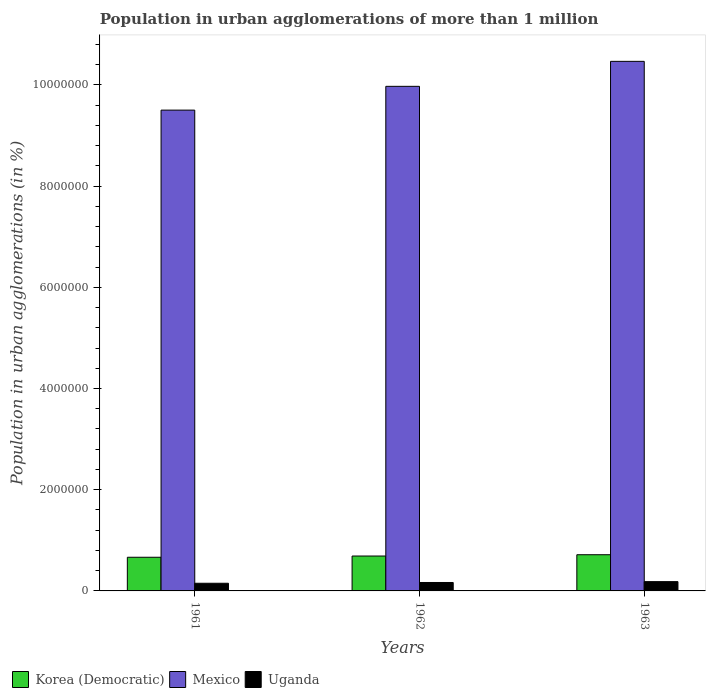How many groups of bars are there?
Your answer should be compact. 3. In how many cases, is the number of bars for a given year not equal to the number of legend labels?
Your answer should be very brief. 0. What is the population in urban agglomerations in Uganda in 1962?
Your response must be concise. 1.67e+05. Across all years, what is the maximum population in urban agglomerations in Mexico?
Your answer should be compact. 1.05e+07. Across all years, what is the minimum population in urban agglomerations in Mexico?
Offer a terse response. 9.50e+06. In which year was the population in urban agglomerations in Korea (Democratic) maximum?
Your answer should be very brief. 1963. In which year was the population in urban agglomerations in Korea (Democratic) minimum?
Provide a succinct answer. 1961. What is the total population in urban agglomerations in Uganda in the graph?
Ensure brevity in your answer.  5.01e+05. What is the difference between the population in urban agglomerations in Uganda in 1961 and that in 1963?
Offer a very short reply. -3.21e+04. What is the difference between the population in urban agglomerations in Korea (Democratic) in 1963 and the population in urban agglomerations in Mexico in 1961?
Ensure brevity in your answer.  -8.79e+06. What is the average population in urban agglomerations in Uganda per year?
Provide a succinct answer. 1.67e+05. In the year 1961, what is the difference between the population in urban agglomerations in Korea (Democratic) and population in urban agglomerations in Uganda?
Your response must be concise. 5.14e+05. In how many years, is the population in urban agglomerations in Uganda greater than 4400000 %?
Give a very brief answer. 0. What is the ratio of the population in urban agglomerations in Mexico in 1962 to that in 1963?
Keep it short and to the point. 0.95. What is the difference between the highest and the second highest population in urban agglomerations in Mexico?
Give a very brief answer. 4.94e+05. What is the difference between the highest and the lowest population in urban agglomerations in Mexico?
Provide a short and direct response. 9.64e+05. Is the sum of the population in urban agglomerations in Korea (Democratic) in 1961 and 1963 greater than the maximum population in urban agglomerations in Mexico across all years?
Your response must be concise. No. What does the 3rd bar from the left in 1963 represents?
Ensure brevity in your answer.  Uganda. What does the 1st bar from the right in 1961 represents?
Keep it short and to the point. Uganda. Is it the case that in every year, the sum of the population in urban agglomerations in Uganda and population in urban agglomerations in Mexico is greater than the population in urban agglomerations in Korea (Democratic)?
Provide a short and direct response. Yes. Are all the bars in the graph horizontal?
Keep it short and to the point. No. How many years are there in the graph?
Your answer should be very brief. 3. What is the difference between two consecutive major ticks on the Y-axis?
Provide a succinct answer. 2.00e+06. Does the graph contain grids?
Make the answer very short. No. Where does the legend appear in the graph?
Provide a short and direct response. Bottom left. How many legend labels are there?
Keep it short and to the point. 3. What is the title of the graph?
Ensure brevity in your answer.  Population in urban agglomerations of more than 1 million. Does "Guyana" appear as one of the legend labels in the graph?
Keep it short and to the point. No. What is the label or title of the Y-axis?
Provide a succinct answer. Population in urban agglomerations (in %). What is the Population in urban agglomerations (in %) of Korea (Democratic) in 1961?
Your answer should be very brief. 6.65e+05. What is the Population in urban agglomerations (in %) in Mexico in 1961?
Offer a very short reply. 9.50e+06. What is the Population in urban agglomerations (in %) of Uganda in 1961?
Offer a very short reply. 1.51e+05. What is the Population in urban agglomerations (in %) of Korea (Democratic) in 1962?
Offer a terse response. 6.90e+05. What is the Population in urban agglomerations (in %) of Mexico in 1962?
Offer a terse response. 9.97e+06. What is the Population in urban agglomerations (in %) in Uganda in 1962?
Provide a succinct answer. 1.67e+05. What is the Population in urban agglomerations (in %) in Korea (Democratic) in 1963?
Provide a short and direct response. 7.15e+05. What is the Population in urban agglomerations (in %) of Mexico in 1963?
Offer a terse response. 1.05e+07. What is the Population in urban agglomerations (in %) in Uganda in 1963?
Ensure brevity in your answer.  1.83e+05. Across all years, what is the maximum Population in urban agglomerations (in %) of Korea (Democratic)?
Keep it short and to the point. 7.15e+05. Across all years, what is the maximum Population in urban agglomerations (in %) in Mexico?
Provide a succinct answer. 1.05e+07. Across all years, what is the maximum Population in urban agglomerations (in %) of Uganda?
Provide a short and direct response. 1.83e+05. Across all years, what is the minimum Population in urban agglomerations (in %) in Korea (Democratic)?
Give a very brief answer. 6.65e+05. Across all years, what is the minimum Population in urban agglomerations (in %) in Mexico?
Ensure brevity in your answer.  9.50e+06. Across all years, what is the minimum Population in urban agglomerations (in %) in Uganda?
Ensure brevity in your answer.  1.51e+05. What is the total Population in urban agglomerations (in %) of Korea (Democratic) in the graph?
Give a very brief answer. 2.07e+06. What is the total Population in urban agglomerations (in %) in Mexico in the graph?
Keep it short and to the point. 2.99e+07. What is the total Population in urban agglomerations (in %) of Uganda in the graph?
Your response must be concise. 5.01e+05. What is the difference between the Population in urban agglomerations (in %) of Korea (Democratic) in 1961 and that in 1962?
Offer a terse response. -2.46e+04. What is the difference between the Population in urban agglomerations (in %) of Mexico in 1961 and that in 1962?
Make the answer very short. -4.70e+05. What is the difference between the Population in urban agglomerations (in %) of Uganda in 1961 and that in 1962?
Give a very brief answer. -1.53e+04. What is the difference between the Population in urban agglomerations (in %) of Korea (Democratic) in 1961 and that in 1963?
Provide a short and direct response. -5.02e+04. What is the difference between the Population in urban agglomerations (in %) in Mexico in 1961 and that in 1963?
Give a very brief answer. -9.64e+05. What is the difference between the Population in urban agglomerations (in %) in Uganda in 1961 and that in 1963?
Keep it short and to the point. -3.21e+04. What is the difference between the Population in urban agglomerations (in %) in Korea (Democratic) in 1962 and that in 1963?
Your response must be concise. -2.56e+04. What is the difference between the Population in urban agglomerations (in %) of Mexico in 1962 and that in 1963?
Offer a terse response. -4.94e+05. What is the difference between the Population in urban agglomerations (in %) in Uganda in 1962 and that in 1963?
Your answer should be compact. -1.68e+04. What is the difference between the Population in urban agglomerations (in %) of Korea (Democratic) in 1961 and the Population in urban agglomerations (in %) of Mexico in 1962?
Your answer should be compact. -9.31e+06. What is the difference between the Population in urban agglomerations (in %) in Korea (Democratic) in 1961 and the Population in urban agglomerations (in %) in Uganda in 1962?
Make the answer very short. 4.98e+05. What is the difference between the Population in urban agglomerations (in %) of Mexico in 1961 and the Population in urban agglomerations (in %) of Uganda in 1962?
Offer a terse response. 9.33e+06. What is the difference between the Population in urban agglomerations (in %) in Korea (Democratic) in 1961 and the Population in urban agglomerations (in %) in Mexico in 1963?
Provide a short and direct response. -9.80e+06. What is the difference between the Population in urban agglomerations (in %) of Korea (Democratic) in 1961 and the Population in urban agglomerations (in %) of Uganda in 1963?
Your answer should be compact. 4.82e+05. What is the difference between the Population in urban agglomerations (in %) in Mexico in 1961 and the Population in urban agglomerations (in %) in Uganda in 1963?
Offer a very short reply. 9.32e+06. What is the difference between the Population in urban agglomerations (in %) in Korea (Democratic) in 1962 and the Population in urban agglomerations (in %) in Mexico in 1963?
Make the answer very short. -9.77e+06. What is the difference between the Population in urban agglomerations (in %) in Korea (Democratic) in 1962 and the Population in urban agglomerations (in %) in Uganda in 1963?
Give a very brief answer. 5.06e+05. What is the difference between the Population in urban agglomerations (in %) in Mexico in 1962 and the Population in urban agglomerations (in %) in Uganda in 1963?
Provide a succinct answer. 9.79e+06. What is the average Population in urban agglomerations (in %) in Korea (Democratic) per year?
Ensure brevity in your answer.  6.90e+05. What is the average Population in urban agglomerations (in %) in Mexico per year?
Give a very brief answer. 9.98e+06. What is the average Population in urban agglomerations (in %) of Uganda per year?
Your answer should be very brief. 1.67e+05. In the year 1961, what is the difference between the Population in urban agglomerations (in %) in Korea (Democratic) and Population in urban agglomerations (in %) in Mexico?
Your answer should be very brief. -8.84e+06. In the year 1961, what is the difference between the Population in urban agglomerations (in %) in Korea (Democratic) and Population in urban agglomerations (in %) in Uganda?
Give a very brief answer. 5.14e+05. In the year 1961, what is the difference between the Population in urban agglomerations (in %) in Mexico and Population in urban agglomerations (in %) in Uganda?
Your answer should be very brief. 9.35e+06. In the year 1962, what is the difference between the Population in urban agglomerations (in %) in Korea (Democratic) and Population in urban agglomerations (in %) in Mexico?
Ensure brevity in your answer.  -9.28e+06. In the year 1962, what is the difference between the Population in urban agglomerations (in %) of Korea (Democratic) and Population in urban agglomerations (in %) of Uganda?
Make the answer very short. 5.23e+05. In the year 1962, what is the difference between the Population in urban agglomerations (in %) of Mexico and Population in urban agglomerations (in %) of Uganda?
Make the answer very short. 9.80e+06. In the year 1963, what is the difference between the Population in urban agglomerations (in %) in Korea (Democratic) and Population in urban agglomerations (in %) in Mexico?
Keep it short and to the point. -9.75e+06. In the year 1963, what is the difference between the Population in urban agglomerations (in %) in Korea (Democratic) and Population in urban agglomerations (in %) in Uganda?
Provide a succinct answer. 5.32e+05. In the year 1963, what is the difference between the Population in urban agglomerations (in %) of Mexico and Population in urban agglomerations (in %) of Uganda?
Offer a terse response. 1.03e+07. What is the ratio of the Population in urban agglomerations (in %) of Mexico in 1961 to that in 1962?
Offer a very short reply. 0.95. What is the ratio of the Population in urban agglomerations (in %) of Uganda in 1961 to that in 1962?
Your response must be concise. 0.91. What is the ratio of the Population in urban agglomerations (in %) of Korea (Democratic) in 1961 to that in 1963?
Give a very brief answer. 0.93. What is the ratio of the Population in urban agglomerations (in %) in Mexico in 1961 to that in 1963?
Offer a very short reply. 0.91. What is the ratio of the Population in urban agglomerations (in %) of Uganda in 1961 to that in 1963?
Your answer should be very brief. 0.83. What is the ratio of the Population in urban agglomerations (in %) in Korea (Democratic) in 1962 to that in 1963?
Provide a succinct answer. 0.96. What is the ratio of the Population in urban agglomerations (in %) of Mexico in 1962 to that in 1963?
Ensure brevity in your answer.  0.95. What is the ratio of the Population in urban agglomerations (in %) of Uganda in 1962 to that in 1963?
Your answer should be very brief. 0.91. What is the difference between the highest and the second highest Population in urban agglomerations (in %) in Korea (Democratic)?
Your answer should be compact. 2.56e+04. What is the difference between the highest and the second highest Population in urban agglomerations (in %) of Mexico?
Ensure brevity in your answer.  4.94e+05. What is the difference between the highest and the second highest Population in urban agglomerations (in %) in Uganda?
Your answer should be compact. 1.68e+04. What is the difference between the highest and the lowest Population in urban agglomerations (in %) of Korea (Democratic)?
Make the answer very short. 5.02e+04. What is the difference between the highest and the lowest Population in urban agglomerations (in %) of Mexico?
Provide a succinct answer. 9.64e+05. What is the difference between the highest and the lowest Population in urban agglomerations (in %) in Uganda?
Your answer should be compact. 3.21e+04. 